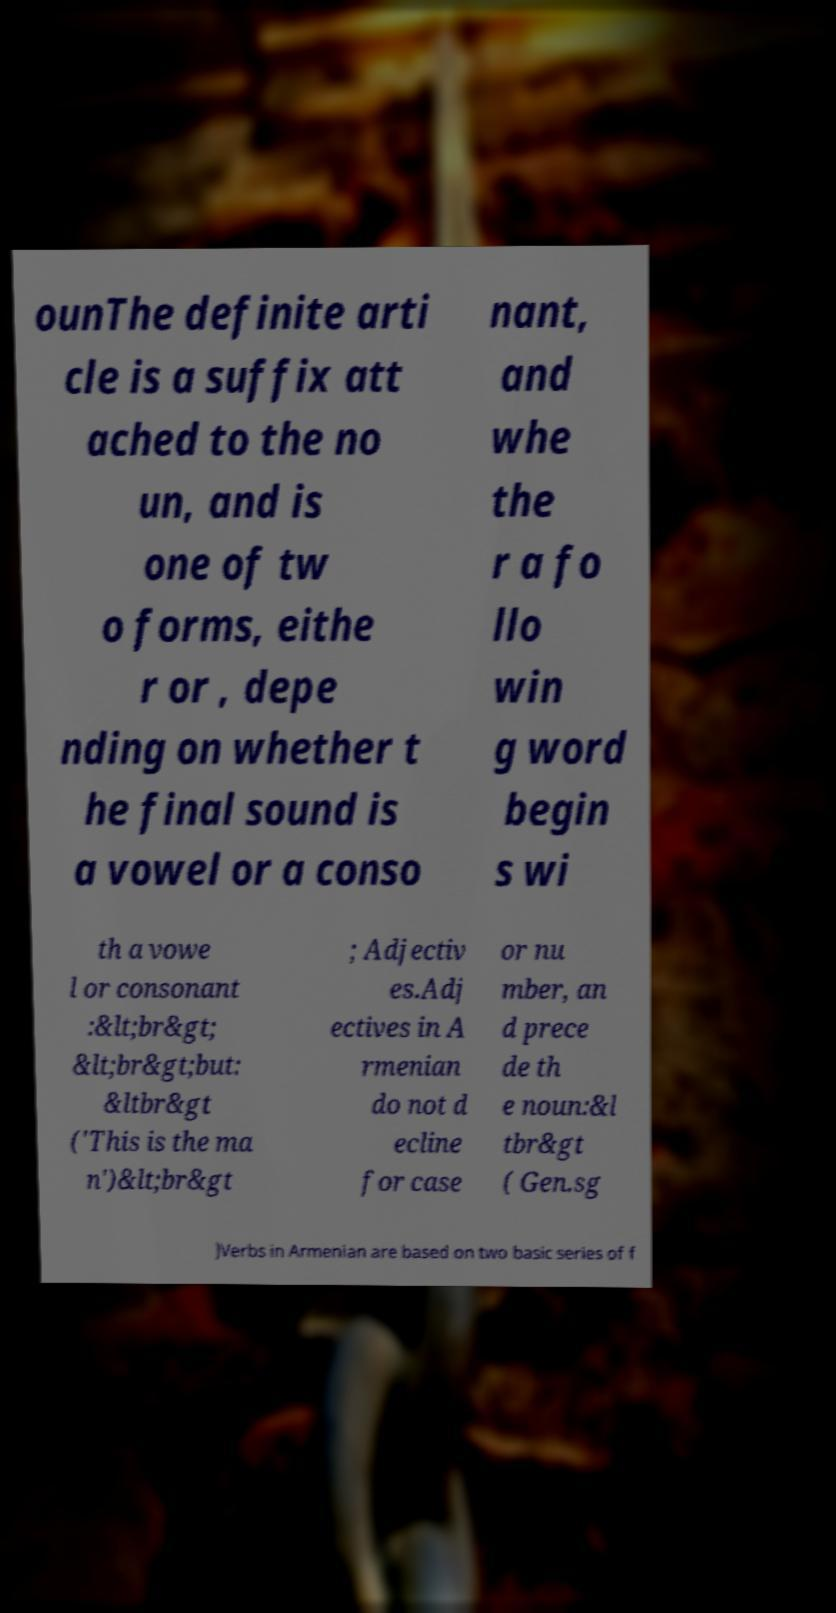Could you extract and type out the text from this image? ounThe definite arti cle is a suffix att ached to the no un, and is one of tw o forms, eithe r or , depe nding on whether t he final sound is a vowel or a conso nant, and whe the r a fo llo win g word begin s wi th a vowe l or consonant :&lt;br&gt; &lt;br&gt;but: &ltbr&gt ('This is the ma n')&lt;br&gt ; Adjectiv es.Adj ectives in A rmenian do not d ecline for case or nu mber, an d prece de th e noun:&l tbr&gt ( Gen.sg )Verbs in Armenian are based on two basic series of f 